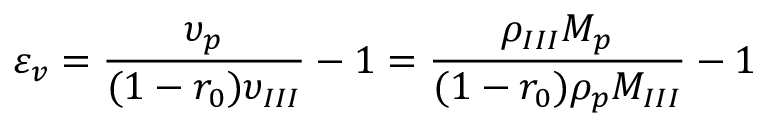<formula> <loc_0><loc_0><loc_500><loc_500>\varepsilon _ { v } = \frac { \upsilon _ { p } } { ( 1 - r _ { 0 } ) \upsilon _ { I I I } } - 1 = \frac { \rho _ { I I I } M _ { p } } { ( 1 - r _ { 0 } ) \rho _ { p } M _ { I I I } } - 1</formula> 